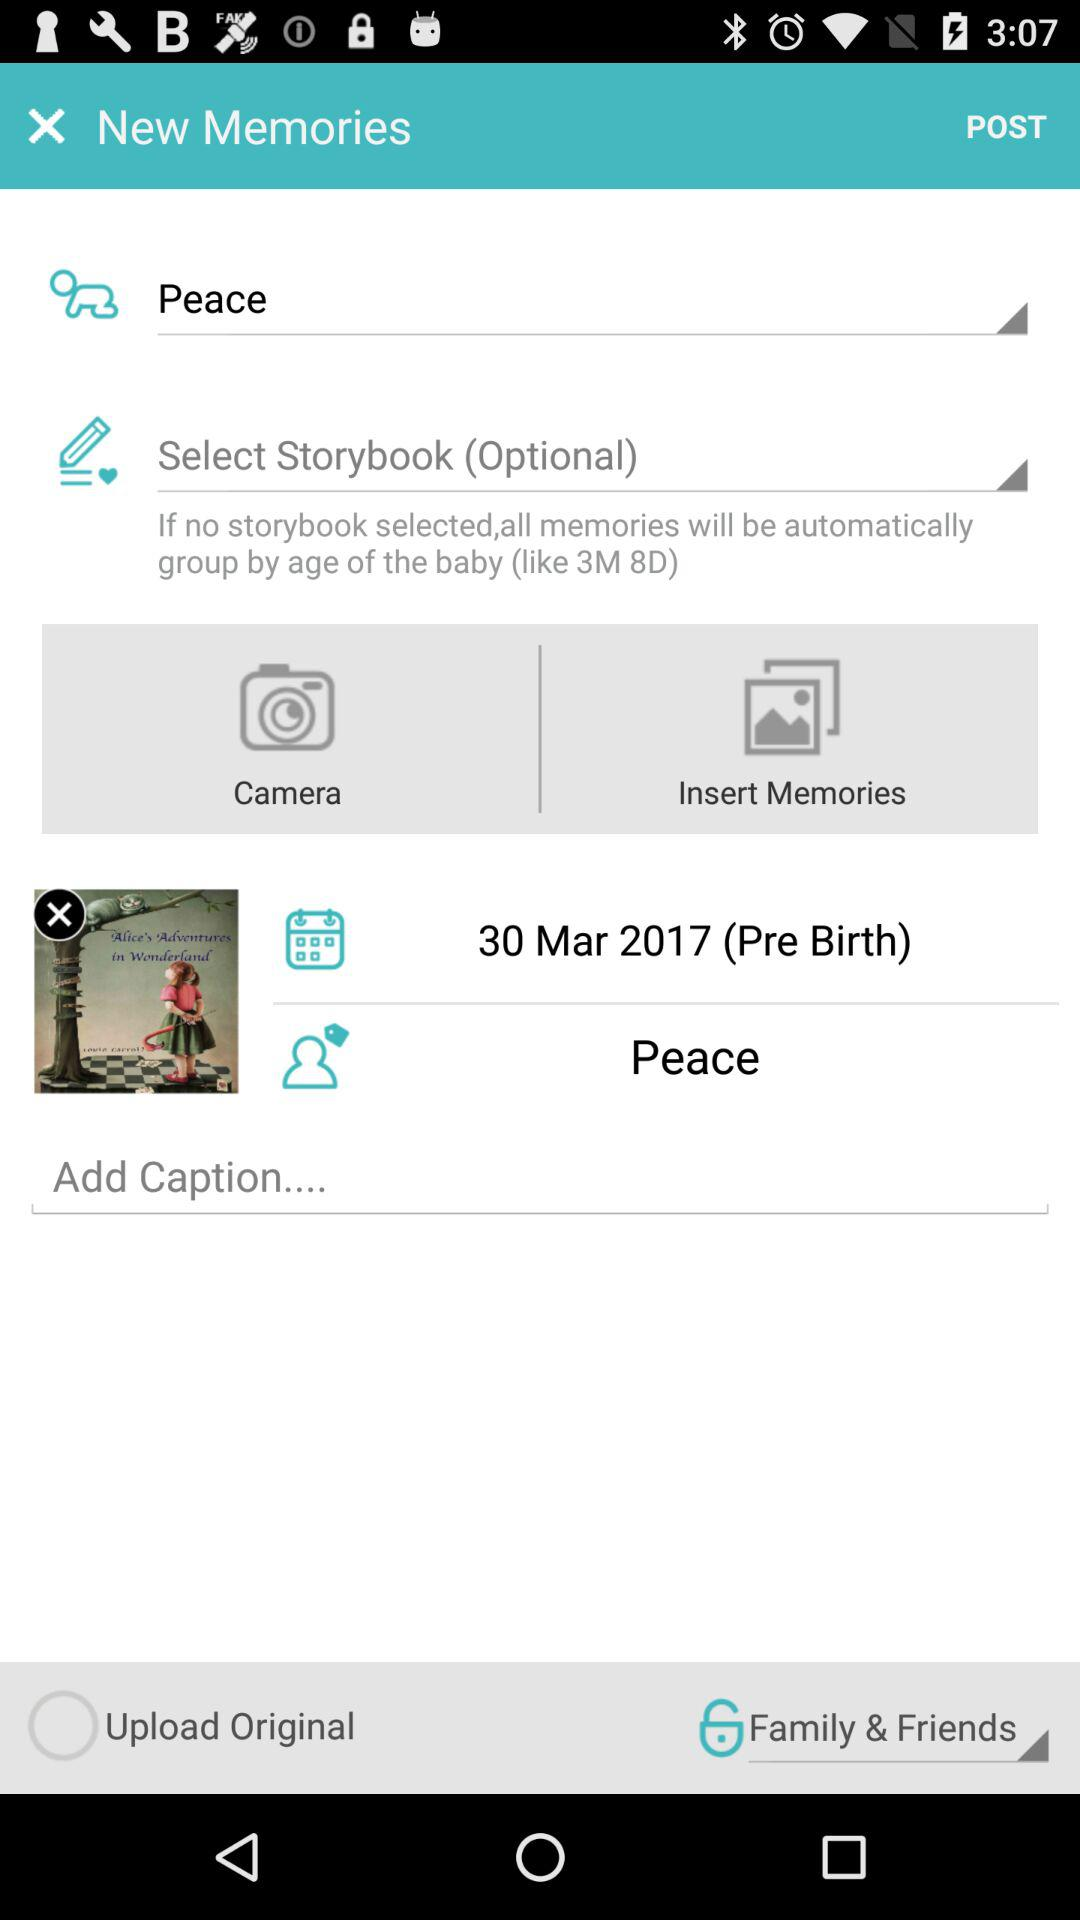How many text inputs have text in them?
Answer the question using a single word or phrase. 2 